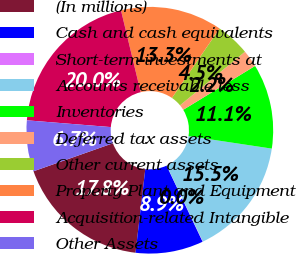Convert chart to OTSL. <chart><loc_0><loc_0><loc_500><loc_500><pie_chart><fcel>(In millions)<fcel>Cash and cash equivalents<fcel>Short-term investments at<fcel>Accounts receivable less<fcel>Inventories<fcel>Deferred tax assets<fcel>Other current assets<fcel>Property Plant and Equipment<fcel>Acquisition-related Intangible<fcel>Other Assets<nl><fcel>17.75%<fcel>8.89%<fcel>0.04%<fcel>15.54%<fcel>11.11%<fcel>2.25%<fcel>4.46%<fcel>13.32%<fcel>19.96%<fcel>6.68%<nl></chart> 